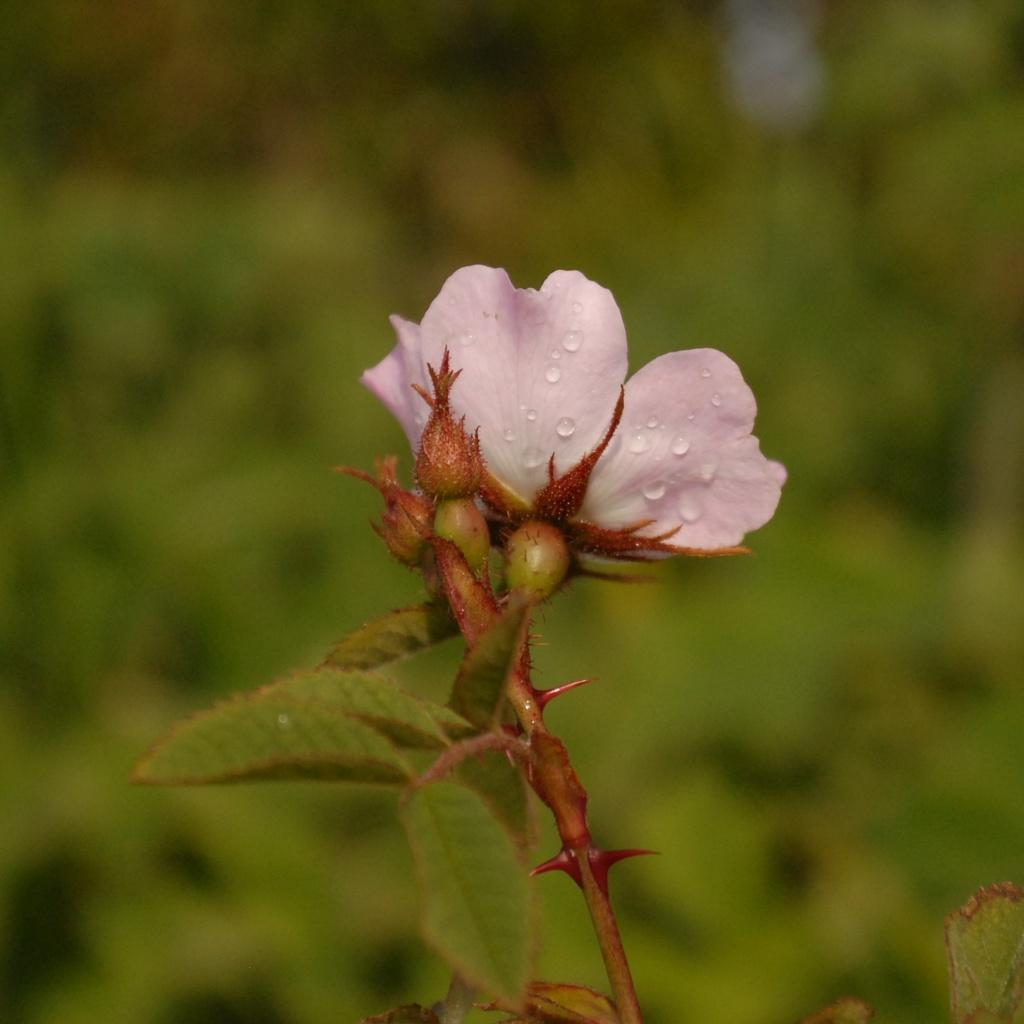What type of plant is visible in the image? There is a flower in the image, which is a type of plant. Can you describe the background of the image? The background of the image is blue and green. What is the tax rate for the flower in the image? There is no tax rate mentioned or implied in the image, as it is a photograph of a flower and not a financial document. 